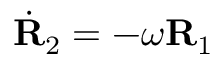Convert formula to latex. <formula><loc_0><loc_0><loc_500><loc_500>\dot { R } _ { 2 } = - \omega { R } _ { 1 }</formula> 